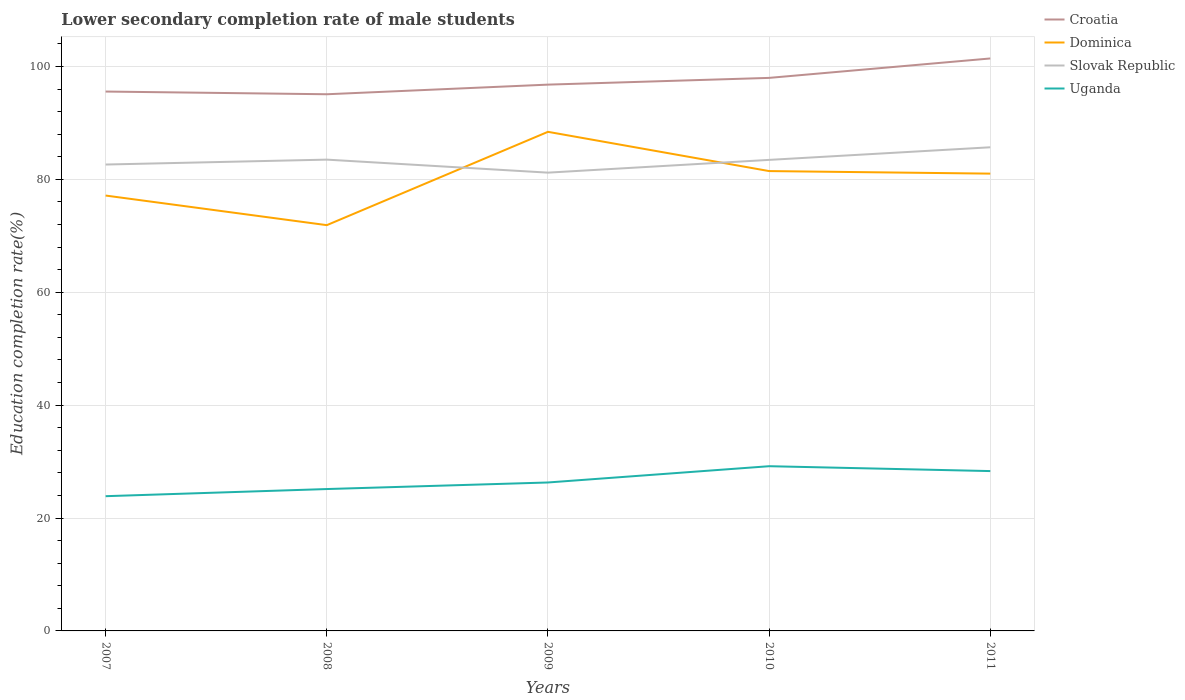Is the number of lines equal to the number of legend labels?
Keep it short and to the point. Yes. Across all years, what is the maximum lower secondary completion rate of male students in Slovak Republic?
Your response must be concise. 81.19. In which year was the lower secondary completion rate of male students in Croatia maximum?
Offer a very short reply. 2008. What is the total lower secondary completion rate of male students in Uganda in the graph?
Offer a very short reply. -4.45. What is the difference between the highest and the second highest lower secondary completion rate of male students in Dominica?
Offer a terse response. 16.53. What is the difference between the highest and the lowest lower secondary completion rate of male students in Uganda?
Provide a short and direct response. 2. Is the lower secondary completion rate of male students in Uganda strictly greater than the lower secondary completion rate of male students in Dominica over the years?
Keep it short and to the point. Yes. How many years are there in the graph?
Ensure brevity in your answer.  5. Does the graph contain any zero values?
Give a very brief answer. No. Does the graph contain grids?
Provide a succinct answer. Yes. How many legend labels are there?
Offer a terse response. 4. What is the title of the graph?
Your response must be concise. Lower secondary completion rate of male students. Does "Peru" appear as one of the legend labels in the graph?
Ensure brevity in your answer.  No. What is the label or title of the Y-axis?
Offer a terse response. Education completion rate(%). What is the Education completion rate(%) in Croatia in 2007?
Your answer should be very brief. 95.56. What is the Education completion rate(%) in Dominica in 2007?
Offer a terse response. 77.13. What is the Education completion rate(%) of Slovak Republic in 2007?
Provide a succinct answer. 82.63. What is the Education completion rate(%) in Uganda in 2007?
Your answer should be compact. 23.87. What is the Education completion rate(%) of Croatia in 2008?
Provide a short and direct response. 95.08. What is the Education completion rate(%) of Dominica in 2008?
Provide a short and direct response. 71.89. What is the Education completion rate(%) of Slovak Republic in 2008?
Offer a very short reply. 83.5. What is the Education completion rate(%) in Uganda in 2008?
Make the answer very short. 25.13. What is the Education completion rate(%) of Croatia in 2009?
Provide a succinct answer. 96.78. What is the Education completion rate(%) in Dominica in 2009?
Keep it short and to the point. 88.42. What is the Education completion rate(%) of Slovak Republic in 2009?
Give a very brief answer. 81.19. What is the Education completion rate(%) of Uganda in 2009?
Your response must be concise. 26.3. What is the Education completion rate(%) of Croatia in 2010?
Your response must be concise. 97.98. What is the Education completion rate(%) of Dominica in 2010?
Make the answer very short. 81.47. What is the Education completion rate(%) of Slovak Republic in 2010?
Provide a short and direct response. 83.45. What is the Education completion rate(%) of Uganda in 2010?
Make the answer very short. 29.18. What is the Education completion rate(%) in Croatia in 2011?
Provide a succinct answer. 101.42. What is the Education completion rate(%) in Dominica in 2011?
Provide a succinct answer. 81.01. What is the Education completion rate(%) in Slovak Republic in 2011?
Your answer should be very brief. 85.68. What is the Education completion rate(%) of Uganda in 2011?
Your response must be concise. 28.32. Across all years, what is the maximum Education completion rate(%) in Croatia?
Offer a very short reply. 101.42. Across all years, what is the maximum Education completion rate(%) in Dominica?
Your answer should be very brief. 88.42. Across all years, what is the maximum Education completion rate(%) in Slovak Republic?
Keep it short and to the point. 85.68. Across all years, what is the maximum Education completion rate(%) in Uganda?
Ensure brevity in your answer.  29.18. Across all years, what is the minimum Education completion rate(%) of Croatia?
Your answer should be compact. 95.08. Across all years, what is the minimum Education completion rate(%) of Dominica?
Make the answer very short. 71.89. Across all years, what is the minimum Education completion rate(%) in Slovak Republic?
Give a very brief answer. 81.19. Across all years, what is the minimum Education completion rate(%) of Uganda?
Provide a succinct answer. 23.87. What is the total Education completion rate(%) of Croatia in the graph?
Keep it short and to the point. 486.81. What is the total Education completion rate(%) of Dominica in the graph?
Your answer should be compact. 399.92. What is the total Education completion rate(%) in Slovak Republic in the graph?
Your answer should be compact. 416.45. What is the total Education completion rate(%) of Uganda in the graph?
Give a very brief answer. 132.8. What is the difference between the Education completion rate(%) in Croatia in 2007 and that in 2008?
Provide a succinct answer. 0.48. What is the difference between the Education completion rate(%) in Dominica in 2007 and that in 2008?
Give a very brief answer. 5.24. What is the difference between the Education completion rate(%) of Slovak Republic in 2007 and that in 2008?
Offer a terse response. -0.87. What is the difference between the Education completion rate(%) of Uganda in 2007 and that in 2008?
Provide a succinct answer. -1.26. What is the difference between the Education completion rate(%) of Croatia in 2007 and that in 2009?
Offer a very short reply. -1.23. What is the difference between the Education completion rate(%) of Dominica in 2007 and that in 2009?
Provide a succinct answer. -11.29. What is the difference between the Education completion rate(%) of Slovak Republic in 2007 and that in 2009?
Offer a terse response. 1.44. What is the difference between the Education completion rate(%) of Uganda in 2007 and that in 2009?
Ensure brevity in your answer.  -2.43. What is the difference between the Education completion rate(%) of Croatia in 2007 and that in 2010?
Your answer should be compact. -2.42. What is the difference between the Education completion rate(%) of Dominica in 2007 and that in 2010?
Your response must be concise. -4.33. What is the difference between the Education completion rate(%) in Slovak Republic in 2007 and that in 2010?
Make the answer very short. -0.82. What is the difference between the Education completion rate(%) in Uganda in 2007 and that in 2010?
Provide a short and direct response. -5.31. What is the difference between the Education completion rate(%) in Croatia in 2007 and that in 2011?
Ensure brevity in your answer.  -5.86. What is the difference between the Education completion rate(%) of Dominica in 2007 and that in 2011?
Give a very brief answer. -3.88. What is the difference between the Education completion rate(%) of Slovak Republic in 2007 and that in 2011?
Ensure brevity in your answer.  -3.06. What is the difference between the Education completion rate(%) in Uganda in 2007 and that in 2011?
Your answer should be very brief. -4.45. What is the difference between the Education completion rate(%) of Croatia in 2008 and that in 2009?
Offer a very short reply. -1.71. What is the difference between the Education completion rate(%) in Dominica in 2008 and that in 2009?
Your answer should be very brief. -16.53. What is the difference between the Education completion rate(%) in Slovak Republic in 2008 and that in 2009?
Offer a terse response. 2.31. What is the difference between the Education completion rate(%) in Uganda in 2008 and that in 2009?
Keep it short and to the point. -1.16. What is the difference between the Education completion rate(%) in Croatia in 2008 and that in 2010?
Provide a succinct answer. -2.9. What is the difference between the Education completion rate(%) of Dominica in 2008 and that in 2010?
Keep it short and to the point. -9.58. What is the difference between the Education completion rate(%) in Slovak Republic in 2008 and that in 2010?
Your answer should be compact. 0.05. What is the difference between the Education completion rate(%) in Uganda in 2008 and that in 2010?
Your answer should be compact. -4.05. What is the difference between the Education completion rate(%) in Croatia in 2008 and that in 2011?
Offer a very short reply. -6.34. What is the difference between the Education completion rate(%) of Dominica in 2008 and that in 2011?
Your response must be concise. -9.13. What is the difference between the Education completion rate(%) in Slovak Republic in 2008 and that in 2011?
Offer a terse response. -2.19. What is the difference between the Education completion rate(%) in Uganda in 2008 and that in 2011?
Provide a succinct answer. -3.19. What is the difference between the Education completion rate(%) of Croatia in 2009 and that in 2010?
Offer a terse response. -1.19. What is the difference between the Education completion rate(%) in Dominica in 2009 and that in 2010?
Your answer should be compact. 6.95. What is the difference between the Education completion rate(%) of Slovak Republic in 2009 and that in 2010?
Give a very brief answer. -2.26. What is the difference between the Education completion rate(%) in Uganda in 2009 and that in 2010?
Provide a succinct answer. -2.88. What is the difference between the Education completion rate(%) of Croatia in 2009 and that in 2011?
Your response must be concise. -4.64. What is the difference between the Education completion rate(%) in Dominica in 2009 and that in 2011?
Offer a very short reply. 7.41. What is the difference between the Education completion rate(%) in Slovak Republic in 2009 and that in 2011?
Make the answer very short. -4.49. What is the difference between the Education completion rate(%) in Uganda in 2009 and that in 2011?
Keep it short and to the point. -2.02. What is the difference between the Education completion rate(%) of Croatia in 2010 and that in 2011?
Provide a succinct answer. -3.44. What is the difference between the Education completion rate(%) in Dominica in 2010 and that in 2011?
Your answer should be compact. 0.45. What is the difference between the Education completion rate(%) in Slovak Republic in 2010 and that in 2011?
Make the answer very short. -2.23. What is the difference between the Education completion rate(%) in Uganda in 2010 and that in 2011?
Keep it short and to the point. 0.86. What is the difference between the Education completion rate(%) in Croatia in 2007 and the Education completion rate(%) in Dominica in 2008?
Ensure brevity in your answer.  23.67. What is the difference between the Education completion rate(%) of Croatia in 2007 and the Education completion rate(%) of Slovak Republic in 2008?
Your answer should be very brief. 12.06. What is the difference between the Education completion rate(%) in Croatia in 2007 and the Education completion rate(%) in Uganda in 2008?
Offer a very short reply. 70.42. What is the difference between the Education completion rate(%) of Dominica in 2007 and the Education completion rate(%) of Slovak Republic in 2008?
Give a very brief answer. -6.36. What is the difference between the Education completion rate(%) of Dominica in 2007 and the Education completion rate(%) of Uganda in 2008?
Your answer should be compact. 52. What is the difference between the Education completion rate(%) in Slovak Republic in 2007 and the Education completion rate(%) in Uganda in 2008?
Keep it short and to the point. 57.49. What is the difference between the Education completion rate(%) in Croatia in 2007 and the Education completion rate(%) in Dominica in 2009?
Make the answer very short. 7.14. What is the difference between the Education completion rate(%) of Croatia in 2007 and the Education completion rate(%) of Slovak Republic in 2009?
Keep it short and to the point. 14.37. What is the difference between the Education completion rate(%) in Croatia in 2007 and the Education completion rate(%) in Uganda in 2009?
Offer a terse response. 69.26. What is the difference between the Education completion rate(%) in Dominica in 2007 and the Education completion rate(%) in Slovak Republic in 2009?
Offer a very short reply. -4.06. What is the difference between the Education completion rate(%) of Dominica in 2007 and the Education completion rate(%) of Uganda in 2009?
Your answer should be very brief. 50.83. What is the difference between the Education completion rate(%) in Slovak Republic in 2007 and the Education completion rate(%) in Uganda in 2009?
Give a very brief answer. 56.33. What is the difference between the Education completion rate(%) of Croatia in 2007 and the Education completion rate(%) of Dominica in 2010?
Offer a very short reply. 14.09. What is the difference between the Education completion rate(%) in Croatia in 2007 and the Education completion rate(%) in Slovak Republic in 2010?
Keep it short and to the point. 12.11. What is the difference between the Education completion rate(%) of Croatia in 2007 and the Education completion rate(%) of Uganda in 2010?
Provide a succinct answer. 66.38. What is the difference between the Education completion rate(%) in Dominica in 2007 and the Education completion rate(%) in Slovak Republic in 2010?
Keep it short and to the point. -6.32. What is the difference between the Education completion rate(%) in Dominica in 2007 and the Education completion rate(%) in Uganda in 2010?
Keep it short and to the point. 47.95. What is the difference between the Education completion rate(%) in Slovak Republic in 2007 and the Education completion rate(%) in Uganda in 2010?
Your answer should be compact. 53.45. What is the difference between the Education completion rate(%) of Croatia in 2007 and the Education completion rate(%) of Dominica in 2011?
Offer a terse response. 14.54. What is the difference between the Education completion rate(%) in Croatia in 2007 and the Education completion rate(%) in Slovak Republic in 2011?
Your response must be concise. 9.87. What is the difference between the Education completion rate(%) of Croatia in 2007 and the Education completion rate(%) of Uganda in 2011?
Make the answer very short. 67.24. What is the difference between the Education completion rate(%) in Dominica in 2007 and the Education completion rate(%) in Slovak Republic in 2011?
Ensure brevity in your answer.  -8.55. What is the difference between the Education completion rate(%) in Dominica in 2007 and the Education completion rate(%) in Uganda in 2011?
Keep it short and to the point. 48.81. What is the difference between the Education completion rate(%) of Slovak Republic in 2007 and the Education completion rate(%) of Uganda in 2011?
Provide a succinct answer. 54.31. What is the difference between the Education completion rate(%) of Croatia in 2008 and the Education completion rate(%) of Dominica in 2009?
Offer a terse response. 6.66. What is the difference between the Education completion rate(%) in Croatia in 2008 and the Education completion rate(%) in Slovak Republic in 2009?
Make the answer very short. 13.89. What is the difference between the Education completion rate(%) in Croatia in 2008 and the Education completion rate(%) in Uganda in 2009?
Provide a succinct answer. 68.78. What is the difference between the Education completion rate(%) of Dominica in 2008 and the Education completion rate(%) of Slovak Republic in 2009?
Your answer should be compact. -9.3. What is the difference between the Education completion rate(%) in Dominica in 2008 and the Education completion rate(%) in Uganda in 2009?
Give a very brief answer. 45.59. What is the difference between the Education completion rate(%) of Slovak Republic in 2008 and the Education completion rate(%) of Uganda in 2009?
Give a very brief answer. 57.2. What is the difference between the Education completion rate(%) in Croatia in 2008 and the Education completion rate(%) in Dominica in 2010?
Provide a succinct answer. 13.61. What is the difference between the Education completion rate(%) in Croatia in 2008 and the Education completion rate(%) in Slovak Republic in 2010?
Give a very brief answer. 11.63. What is the difference between the Education completion rate(%) of Croatia in 2008 and the Education completion rate(%) of Uganda in 2010?
Your response must be concise. 65.9. What is the difference between the Education completion rate(%) of Dominica in 2008 and the Education completion rate(%) of Slovak Republic in 2010?
Offer a very short reply. -11.56. What is the difference between the Education completion rate(%) in Dominica in 2008 and the Education completion rate(%) in Uganda in 2010?
Keep it short and to the point. 42.71. What is the difference between the Education completion rate(%) of Slovak Republic in 2008 and the Education completion rate(%) of Uganda in 2010?
Your answer should be very brief. 54.32. What is the difference between the Education completion rate(%) in Croatia in 2008 and the Education completion rate(%) in Dominica in 2011?
Offer a terse response. 14.06. What is the difference between the Education completion rate(%) in Croatia in 2008 and the Education completion rate(%) in Slovak Republic in 2011?
Give a very brief answer. 9.39. What is the difference between the Education completion rate(%) of Croatia in 2008 and the Education completion rate(%) of Uganda in 2011?
Provide a short and direct response. 66.76. What is the difference between the Education completion rate(%) of Dominica in 2008 and the Education completion rate(%) of Slovak Republic in 2011?
Keep it short and to the point. -13.8. What is the difference between the Education completion rate(%) in Dominica in 2008 and the Education completion rate(%) in Uganda in 2011?
Offer a very short reply. 43.57. What is the difference between the Education completion rate(%) of Slovak Republic in 2008 and the Education completion rate(%) of Uganda in 2011?
Your answer should be compact. 55.18. What is the difference between the Education completion rate(%) in Croatia in 2009 and the Education completion rate(%) in Dominica in 2010?
Your response must be concise. 15.32. What is the difference between the Education completion rate(%) in Croatia in 2009 and the Education completion rate(%) in Slovak Republic in 2010?
Offer a terse response. 13.33. What is the difference between the Education completion rate(%) of Croatia in 2009 and the Education completion rate(%) of Uganda in 2010?
Provide a short and direct response. 67.6. What is the difference between the Education completion rate(%) in Dominica in 2009 and the Education completion rate(%) in Slovak Republic in 2010?
Keep it short and to the point. 4.97. What is the difference between the Education completion rate(%) in Dominica in 2009 and the Education completion rate(%) in Uganda in 2010?
Make the answer very short. 59.24. What is the difference between the Education completion rate(%) in Slovak Republic in 2009 and the Education completion rate(%) in Uganda in 2010?
Provide a short and direct response. 52.01. What is the difference between the Education completion rate(%) of Croatia in 2009 and the Education completion rate(%) of Dominica in 2011?
Ensure brevity in your answer.  15.77. What is the difference between the Education completion rate(%) in Croatia in 2009 and the Education completion rate(%) in Slovak Republic in 2011?
Offer a very short reply. 11.1. What is the difference between the Education completion rate(%) of Croatia in 2009 and the Education completion rate(%) of Uganda in 2011?
Make the answer very short. 68.46. What is the difference between the Education completion rate(%) in Dominica in 2009 and the Education completion rate(%) in Slovak Republic in 2011?
Make the answer very short. 2.74. What is the difference between the Education completion rate(%) in Dominica in 2009 and the Education completion rate(%) in Uganda in 2011?
Your answer should be compact. 60.1. What is the difference between the Education completion rate(%) of Slovak Republic in 2009 and the Education completion rate(%) of Uganda in 2011?
Your answer should be compact. 52.87. What is the difference between the Education completion rate(%) of Croatia in 2010 and the Education completion rate(%) of Dominica in 2011?
Make the answer very short. 16.96. What is the difference between the Education completion rate(%) of Croatia in 2010 and the Education completion rate(%) of Slovak Republic in 2011?
Offer a very short reply. 12.29. What is the difference between the Education completion rate(%) in Croatia in 2010 and the Education completion rate(%) in Uganda in 2011?
Offer a terse response. 69.66. What is the difference between the Education completion rate(%) in Dominica in 2010 and the Education completion rate(%) in Slovak Republic in 2011?
Keep it short and to the point. -4.22. What is the difference between the Education completion rate(%) in Dominica in 2010 and the Education completion rate(%) in Uganda in 2011?
Offer a very short reply. 53.15. What is the difference between the Education completion rate(%) of Slovak Republic in 2010 and the Education completion rate(%) of Uganda in 2011?
Offer a very short reply. 55.13. What is the average Education completion rate(%) in Croatia per year?
Give a very brief answer. 97.36. What is the average Education completion rate(%) of Dominica per year?
Offer a terse response. 79.98. What is the average Education completion rate(%) in Slovak Republic per year?
Your answer should be very brief. 83.29. What is the average Education completion rate(%) of Uganda per year?
Provide a short and direct response. 26.56. In the year 2007, what is the difference between the Education completion rate(%) in Croatia and Education completion rate(%) in Dominica?
Your answer should be compact. 18.42. In the year 2007, what is the difference between the Education completion rate(%) in Croatia and Education completion rate(%) in Slovak Republic?
Ensure brevity in your answer.  12.93. In the year 2007, what is the difference between the Education completion rate(%) of Croatia and Education completion rate(%) of Uganda?
Your response must be concise. 71.69. In the year 2007, what is the difference between the Education completion rate(%) in Dominica and Education completion rate(%) in Slovak Republic?
Your response must be concise. -5.49. In the year 2007, what is the difference between the Education completion rate(%) in Dominica and Education completion rate(%) in Uganda?
Provide a succinct answer. 53.26. In the year 2007, what is the difference between the Education completion rate(%) in Slovak Republic and Education completion rate(%) in Uganda?
Your response must be concise. 58.76. In the year 2008, what is the difference between the Education completion rate(%) of Croatia and Education completion rate(%) of Dominica?
Your answer should be very brief. 23.19. In the year 2008, what is the difference between the Education completion rate(%) in Croatia and Education completion rate(%) in Slovak Republic?
Offer a terse response. 11.58. In the year 2008, what is the difference between the Education completion rate(%) of Croatia and Education completion rate(%) of Uganda?
Provide a succinct answer. 69.94. In the year 2008, what is the difference between the Education completion rate(%) of Dominica and Education completion rate(%) of Slovak Republic?
Offer a terse response. -11.61. In the year 2008, what is the difference between the Education completion rate(%) of Dominica and Education completion rate(%) of Uganda?
Your answer should be compact. 46.75. In the year 2008, what is the difference between the Education completion rate(%) of Slovak Republic and Education completion rate(%) of Uganda?
Provide a short and direct response. 58.36. In the year 2009, what is the difference between the Education completion rate(%) in Croatia and Education completion rate(%) in Dominica?
Provide a succinct answer. 8.36. In the year 2009, what is the difference between the Education completion rate(%) of Croatia and Education completion rate(%) of Slovak Republic?
Give a very brief answer. 15.59. In the year 2009, what is the difference between the Education completion rate(%) of Croatia and Education completion rate(%) of Uganda?
Offer a very short reply. 70.48. In the year 2009, what is the difference between the Education completion rate(%) of Dominica and Education completion rate(%) of Slovak Republic?
Keep it short and to the point. 7.23. In the year 2009, what is the difference between the Education completion rate(%) in Dominica and Education completion rate(%) in Uganda?
Make the answer very short. 62.12. In the year 2009, what is the difference between the Education completion rate(%) of Slovak Republic and Education completion rate(%) of Uganda?
Offer a very short reply. 54.89. In the year 2010, what is the difference between the Education completion rate(%) of Croatia and Education completion rate(%) of Dominica?
Your answer should be very brief. 16.51. In the year 2010, what is the difference between the Education completion rate(%) of Croatia and Education completion rate(%) of Slovak Republic?
Make the answer very short. 14.53. In the year 2010, what is the difference between the Education completion rate(%) in Croatia and Education completion rate(%) in Uganda?
Your answer should be very brief. 68.8. In the year 2010, what is the difference between the Education completion rate(%) in Dominica and Education completion rate(%) in Slovak Republic?
Offer a very short reply. -1.98. In the year 2010, what is the difference between the Education completion rate(%) of Dominica and Education completion rate(%) of Uganda?
Ensure brevity in your answer.  52.29. In the year 2010, what is the difference between the Education completion rate(%) in Slovak Republic and Education completion rate(%) in Uganda?
Make the answer very short. 54.27. In the year 2011, what is the difference between the Education completion rate(%) of Croatia and Education completion rate(%) of Dominica?
Provide a short and direct response. 20.4. In the year 2011, what is the difference between the Education completion rate(%) in Croatia and Education completion rate(%) in Slovak Republic?
Offer a very short reply. 15.74. In the year 2011, what is the difference between the Education completion rate(%) in Croatia and Education completion rate(%) in Uganda?
Your answer should be very brief. 73.1. In the year 2011, what is the difference between the Education completion rate(%) in Dominica and Education completion rate(%) in Slovak Republic?
Offer a terse response. -4.67. In the year 2011, what is the difference between the Education completion rate(%) in Dominica and Education completion rate(%) in Uganda?
Keep it short and to the point. 52.7. In the year 2011, what is the difference between the Education completion rate(%) of Slovak Republic and Education completion rate(%) of Uganda?
Your answer should be compact. 57.36. What is the ratio of the Education completion rate(%) in Croatia in 2007 to that in 2008?
Keep it short and to the point. 1.01. What is the ratio of the Education completion rate(%) of Dominica in 2007 to that in 2008?
Offer a very short reply. 1.07. What is the ratio of the Education completion rate(%) of Slovak Republic in 2007 to that in 2008?
Keep it short and to the point. 0.99. What is the ratio of the Education completion rate(%) of Uganda in 2007 to that in 2008?
Your response must be concise. 0.95. What is the ratio of the Education completion rate(%) in Croatia in 2007 to that in 2009?
Offer a terse response. 0.99. What is the ratio of the Education completion rate(%) of Dominica in 2007 to that in 2009?
Offer a very short reply. 0.87. What is the ratio of the Education completion rate(%) of Slovak Republic in 2007 to that in 2009?
Give a very brief answer. 1.02. What is the ratio of the Education completion rate(%) in Uganda in 2007 to that in 2009?
Provide a succinct answer. 0.91. What is the ratio of the Education completion rate(%) in Croatia in 2007 to that in 2010?
Your answer should be very brief. 0.98. What is the ratio of the Education completion rate(%) of Dominica in 2007 to that in 2010?
Your response must be concise. 0.95. What is the ratio of the Education completion rate(%) in Slovak Republic in 2007 to that in 2010?
Your response must be concise. 0.99. What is the ratio of the Education completion rate(%) in Uganda in 2007 to that in 2010?
Offer a terse response. 0.82. What is the ratio of the Education completion rate(%) of Croatia in 2007 to that in 2011?
Make the answer very short. 0.94. What is the ratio of the Education completion rate(%) of Dominica in 2007 to that in 2011?
Your response must be concise. 0.95. What is the ratio of the Education completion rate(%) in Uganda in 2007 to that in 2011?
Offer a terse response. 0.84. What is the ratio of the Education completion rate(%) of Croatia in 2008 to that in 2009?
Your answer should be compact. 0.98. What is the ratio of the Education completion rate(%) of Dominica in 2008 to that in 2009?
Provide a succinct answer. 0.81. What is the ratio of the Education completion rate(%) of Slovak Republic in 2008 to that in 2009?
Provide a succinct answer. 1.03. What is the ratio of the Education completion rate(%) of Uganda in 2008 to that in 2009?
Your answer should be compact. 0.96. What is the ratio of the Education completion rate(%) in Croatia in 2008 to that in 2010?
Your answer should be compact. 0.97. What is the ratio of the Education completion rate(%) in Dominica in 2008 to that in 2010?
Keep it short and to the point. 0.88. What is the ratio of the Education completion rate(%) of Uganda in 2008 to that in 2010?
Provide a succinct answer. 0.86. What is the ratio of the Education completion rate(%) of Dominica in 2008 to that in 2011?
Your response must be concise. 0.89. What is the ratio of the Education completion rate(%) of Slovak Republic in 2008 to that in 2011?
Your answer should be compact. 0.97. What is the ratio of the Education completion rate(%) of Uganda in 2008 to that in 2011?
Offer a terse response. 0.89. What is the ratio of the Education completion rate(%) in Croatia in 2009 to that in 2010?
Offer a very short reply. 0.99. What is the ratio of the Education completion rate(%) in Dominica in 2009 to that in 2010?
Make the answer very short. 1.09. What is the ratio of the Education completion rate(%) of Slovak Republic in 2009 to that in 2010?
Your response must be concise. 0.97. What is the ratio of the Education completion rate(%) of Uganda in 2009 to that in 2010?
Keep it short and to the point. 0.9. What is the ratio of the Education completion rate(%) of Croatia in 2009 to that in 2011?
Your answer should be compact. 0.95. What is the ratio of the Education completion rate(%) of Dominica in 2009 to that in 2011?
Offer a terse response. 1.09. What is the ratio of the Education completion rate(%) of Slovak Republic in 2009 to that in 2011?
Your answer should be very brief. 0.95. What is the ratio of the Education completion rate(%) of Croatia in 2010 to that in 2011?
Your answer should be compact. 0.97. What is the ratio of the Education completion rate(%) of Dominica in 2010 to that in 2011?
Keep it short and to the point. 1.01. What is the ratio of the Education completion rate(%) of Slovak Republic in 2010 to that in 2011?
Offer a very short reply. 0.97. What is the ratio of the Education completion rate(%) of Uganda in 2010 to that in 2011?
Make the answer very short. 1.03. What is the difference between the highest and the second highest Education completion rate(%) in Croatia?
Offer a very short reply. 3.44. What is the difference between the highest and the second highest Education completion rate(%) in Dominica?
Your response must be concise. 6.95. What is the difference between the highest and the second highest Education completion rate(%) in Slovak Republic?
Your answer should be very brief. 2.19. What is the difference between the highest and the second highest Education completion rate(%) of Uganda?
Offer a terse response. 0.86. What is the difference between the highest and the lowest Education completion rate(%) in Croatia?
Give a very brief answer. 6.34. What is the difference between the highest and the lowest Education completion rate(%) in Dominica?
Provide a short and direct response. 16.53. What is the difference between the highest and the lowest Education completion rate(%) in Slovak Republic?
Keep it short and to the point. 4.49. What is the difference between the highest and the lowest Education completion rate(%) of Uganda?
Offer a very short reply. 5.31. 